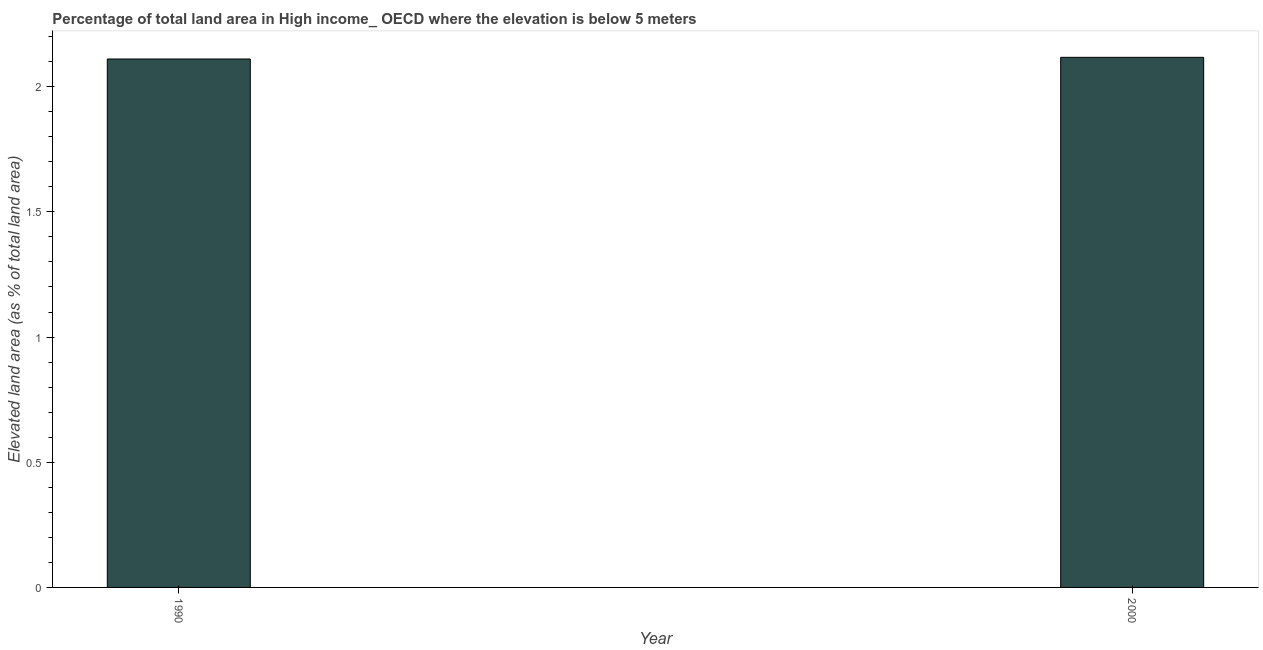Does the graph contain grids?
Make the answer very short. No. What is the title of the graph?
Your answer should be very brief. Percentage of total land area in High income_ OECD where the elevation is below 5 meters. What is the label or title of the Y-axis?
Provide a succinct answer. Elevated land area (as % of total land area). What is the total elevated land area in 2000?
Keep it short and to the point. 2.12. Across all years, what is the maximum total elevated land area?
Your answer should be very brief. 2.12. Across all years, what is the minimum total elevated land area?
Provide a succinct answer. 2.11. What is the sum of the total elevated land area?
Your answer should be very brief. 4.23. What is the difference between the total elevated land area in 1990 and 2000?
Provide a succinct answer. -0.01. What is the average total elevated land area per year?
Provide a succinct answer. 2.11. What is the median total elevated land area?
Ensure brevity in your answer.  2.11. In how many years, is the total elevated land area greater than 1.4 %?
Offer a very short reply. 2. Do a majority of the years between 1990 and 2000 (inclusive) have total elevated land area greater than 2 %?
Make the answer very short. Yes. What is the ratio of the total elevated land area in 1990 to that in 2000?
Give a very brief answer. 1. In how many years, is the total elevated land area greater than the average total elevated land area taken over all years?
Offer a terse response. 1. How many bars are there?
Ensure brevity in your answer.  2. How many years are there in the graph?
Provide a short and direct response. 2. What is the difference between two consecutive major ticks on the Y-axis?
Provide a succinct answer. 0.5. What is the Elevated land area (as % of total land area) in 1990?
Your response must be concise. 2.11. What is the Elevated land area (as % of total land area) of 2000?
Offer a terse response. 2.12. What is the difference between the Elevated land area (as % of total land area) in 1990 and 2000?
Keep it short and to the point. -0.01. What is the ratio of the Elevated land area (as % of total land area) in 1990 to that in 2000?
Make the answer very short. 1. 